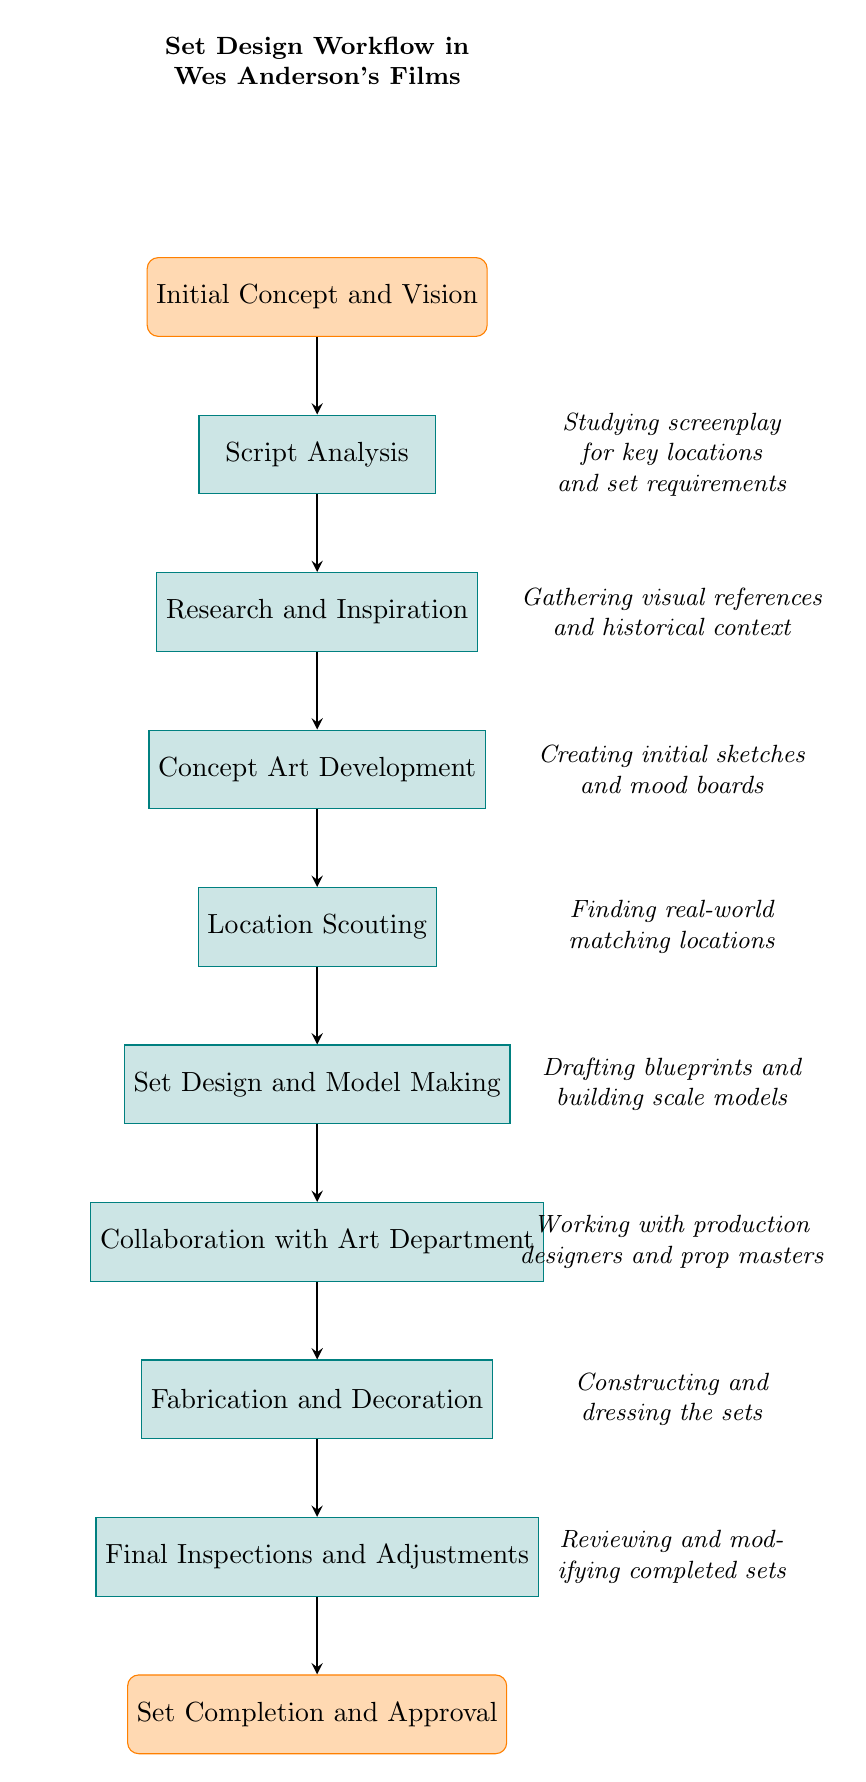What is the first step in the set design workflow? The first node in the diagram is "Initial Concept and Vision," indicating it's the starting point of the workflow.
Answer: Initial Concept and Vision How many nodes are there in total? Counting all steps from "Initial Concept and Vision" to "Set Completion and Approval," there are a total of 9 nodes in the diagram.
Answer: 9 What does the "Collaboration with Art Department" node involve? This node focuses on the teamwork aspect of set design, highlighting the necessity of collaborating with production designers, set decorators, and prop masters.
Answer: Working with production designers, set decorators, and prop masters What comes after "Concept Art Development"? The next step directly flowing from "Concept Art Development" in the diagram is "Location Scouting." This indicates the progression from art concepts to finding physical locations.
Answer: Location Scouting What is the last step before set completion? According to the flow, the last step before reaching "Set Completion and Approval" is "Final Inspections and Adjustments," which involves reviewing the sets for accuracy.
Answer: Final Inspections and Adjustments Which step is responsible for creating initial sketches? "Concept Art Development" is the step noted in the diagram where initial sketches and mood boards are crafted, aiming to convey thematic elements.
Answer: Concept Art Development What is the relationship between "Script Analysis" and "Final Inspections and Adjustments"? "Script Analysis" is the starting point, and it is the first node in the workflow. "Final Inspections and Adjustments" is the last node, showing a direct progression from script analysis to final checks.
Answer: They are the first and last nodes, respectively Which process involves "Constructing and dressing the sets"? The step that specifically involves constructing and dressing the sets is "Fabrication and Decoration," which focuses on the physical creation of the set elements.
Answer: Fabrication and Decoration What is the purpose of "Location Scouting" in the diagram? "Location Scouting" serves the purpose of finding real-world locations that match the set concepts, making it critical for aligning the visuals with the artistic vision laid out in earlier steps.
Answer: Finding real-world locations that match the conceptual and visual elements 